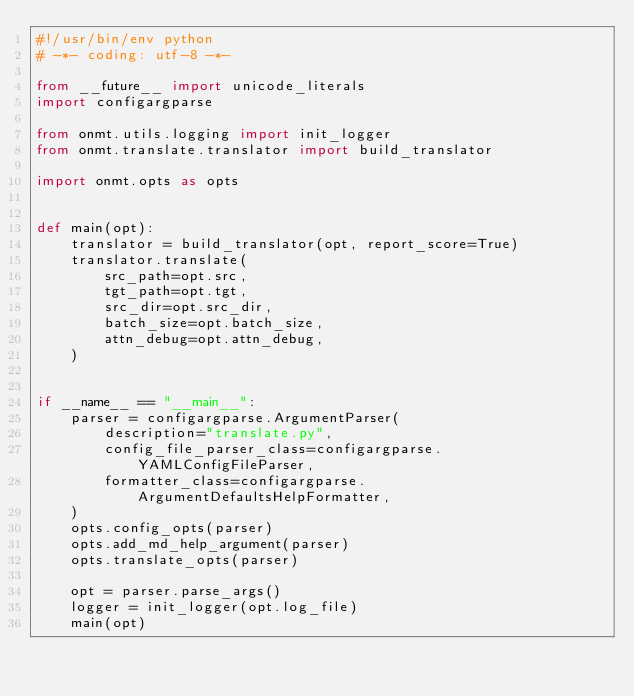Convert code to text. <code><loc_0><loc_0><loc_500><loc_500><_Python_>#!/usr/bin/env python
# -*- coding: utf-8 -*-

from __future__ import unicode_literals
import configargparse

from onmt.utils.logging import init_logger
from onmt.translate.translator import build_translator

import onmt.opts as opts


def main(opt):
    translator = build_translator(opt, report_score=True)
    translator.translate(
        src_path=opt.src,
        tgt_path=opt.tgt,
        src_dir=opt.src_dir,
        batch_size=opt.batch_size,
        attn_debug=opt.attn_debug,
    )


if __name__ == "__main__":
    parser = configargparse.ArgumentParser(
        description="translate.py",
        config_file_parser_class=configargparse.YAMLConfigFileParser,
        formatter_class=configargparse.ArgumentDefaultsHelpFormatter,
    )
    opts.config_opts(parser)
    opts.add_md_help_argument(parser)
    opts.translate_opts(parser)

    opt = parser.parse_args()
    logger = init_logger(opt.log_file)
    main(opt)
</code> 